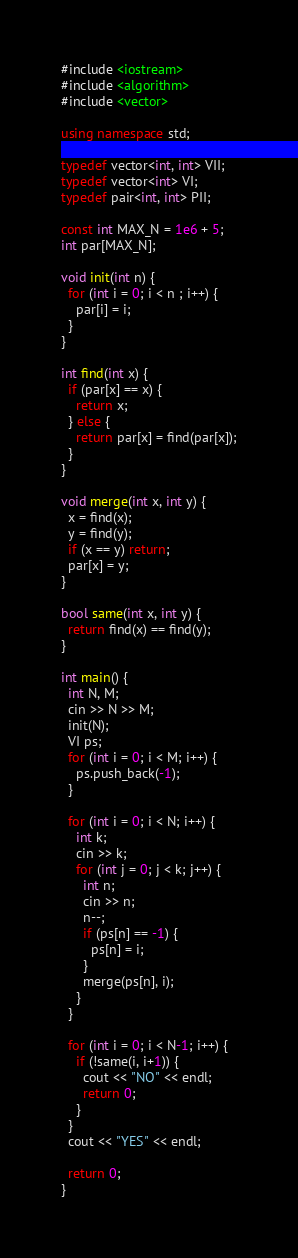Convert code to text. <code><loc_0><loc_0><loc_500><loc_500><_C++_>#include <iostream>
#include <algorithm>
#include <vector>

using namespace std;

typedef vector<int, int> VII;
typedef vector<int> VI;
typedef pair<int, int> PII;

const int MAX_N = 1e6 + 5;
int par[MAX_N];

void init(int n) {
  for (int i = 0; i < n ; i++) {
    par[i] = i;
  }
}

int find(int x) {
  if (par[x] == x) {
    return x;
  } else {
    return par[x] = find(par[x]);
  }
}

void merge(int x, int y) {
  x = find(x);
  y = find(y);
  if (x == y) return;
  par[x] = y;
}

bool same(int x, int y) {
  return find(x) == find(y);
}

int main() {
  int N, M;
  cin >> N >> M;
  init(N);
  VI ps;
  for (int i = 0; i < M; i++) {
    ps.push_back(-1);
  }

  for (int i = 0; i < N; i++) {
    int k;
    cin >> k;
    for (int j = 0; j < k; j++) {
      int n;
      cin >> n;
      n--;
      if (ps[n] == -1) {
        ps[n] = i;
      }
      merge(ps[n], i);
    }
  }

  for (int i = 0; i < N-1; i++) {
    if (!same(i, i+1)) {
      cout << "NO" << endl;
      return 0;
    }
  }
  cout << "YES" << endl;

  return 0;
}
</code> 